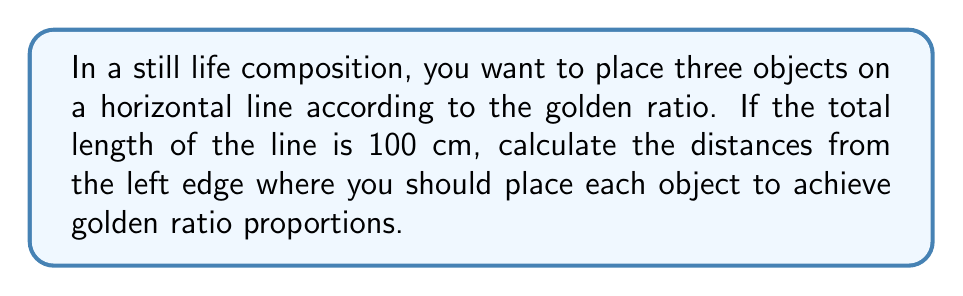What is the answer to this math problem? To solve this problem, we need to use the properties of the golden ratio, denoted by φ (phi). The golden ratio is approximately 1.618033988749895.

1) First, let's divide the total length into two sections according to the golden ratio:
   $$\frac{100}{x} = \frac{x}{100-x} = \phi$$

2) Solving this equation:
   $$x^2 = 100(100-x)$$
   $$x^2 = 10000 - 100x$$
   $$x^2 + 100x - 10000 = 0$$

3) Using the quadratic formula:
   $$x = \frac{-100 + \sqrt{100^2 + 4(1)(10000)}}{2(1)} \approx 61.8034 \text{ cm}$$

4) This gives us the position of the second object. The first object should be placed at 0 cm (the left edge).

5) For the third object, we need to divide the remaining space (100 - 61.8034 = 38.1966 cm) according to the golden ratio again:
   $$38.1966 / y = y / (38.1966 - y) = \phi$$

6) Solving this equation:
   $$y \approx 23.6068 \text{ cm}$$

7) The position of the third object from the left edge is:
   $$61.8034 + 23.6068 = 85.4102 \text{ cm}$$

[asy]
size(300,100);
draw((0,0)--(300,0));
draw((0,-5)--(0,5));
draw((190,-5)--(190,5));
draw((261,-5)--(261,5));
draw((300,-5)--(300,5));
label("0 cm", (0,-15));
label("61.8 cm", (190,-15));
label("85.4 cm", (261,-15));
label("100 cm", (300,-15));
[/asy]
Answer: The objects should be placed at approximately 0 cm, 61.8 cm, and 85.4 cm from the left edge of the 100 cm line. 